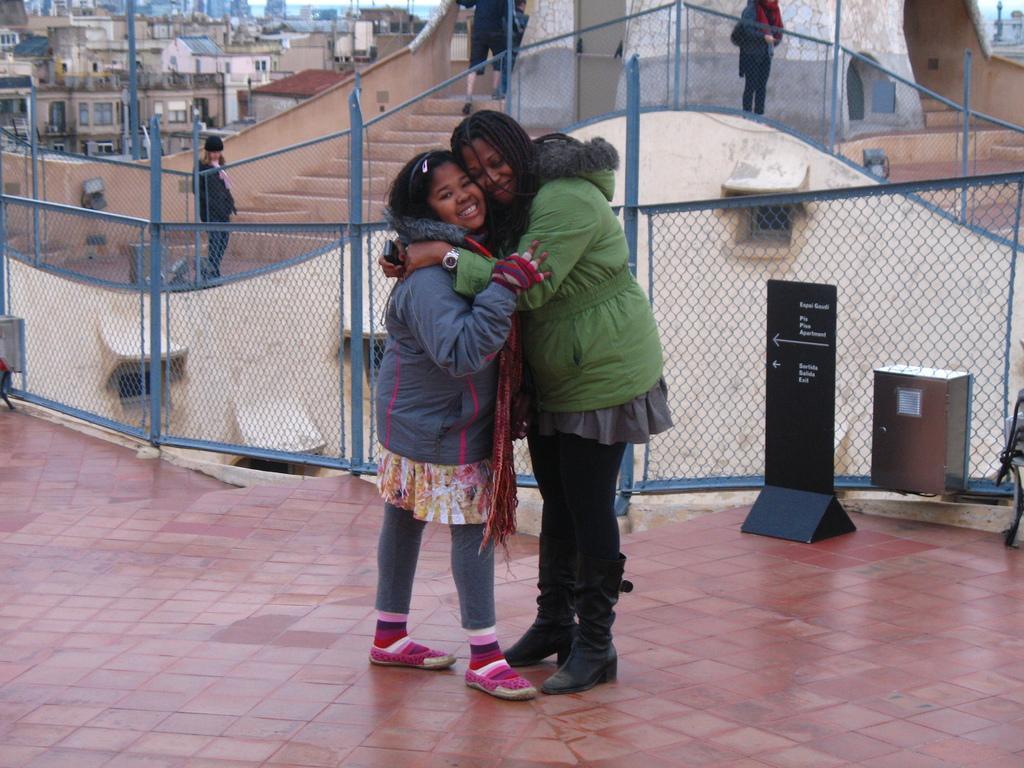How would you summarize this image in a sentence or two? In the image we can see there are two people hugging each other and they are wearing jackets. Behind there are other people standing and there are lot of buildings at the back. 